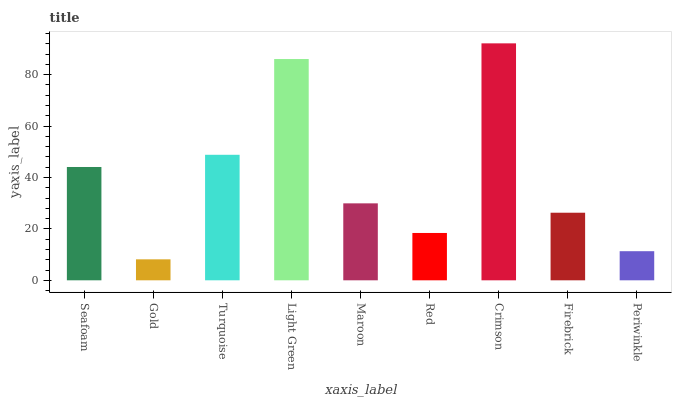Is Gold the minimum?
Answer yes or no. Yes. Is Crimson the maximum?
Answer yes or no. Yes. Is Turquoise the minimum?
Answer yes or no. No. Is Turquoise the maximum?
Answer yes or no. No. Is Turquoise greater than Gold?
Answer yes or no. Yes. Is Gold less than Turquoise?
Answer yes or no. Yes. Is Gold greater than Turquoise?
Answer yes or no. No. Is Turquoise less than Gold?
Answer yes or no. No. Is Maroon the high median?
Answer yes or no. Yes. Is Maroon the low median?
Answer yes or no. Yes. Is Firebrick the high median?
Answer yes or no. No. Is Crimson the low median?
Answer yes or no. No. 